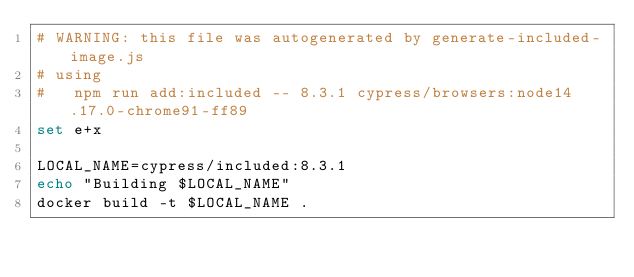Convert code to text. <code><loc_0><loc_0><loc_500><loc_500><_Bash_># WARNING: this file was autogenerated by generate-included-image.js
# using
#   npm run add:included -- 8.3.1 cypress/browsers:node14.17.0-chrome91-ff89
set e+x

LOCAL_NAME=cypress/included:8.3.1
echo "Building $LOCAL_NAME"
docker build -t $LOCAL_NAME .
</code> 